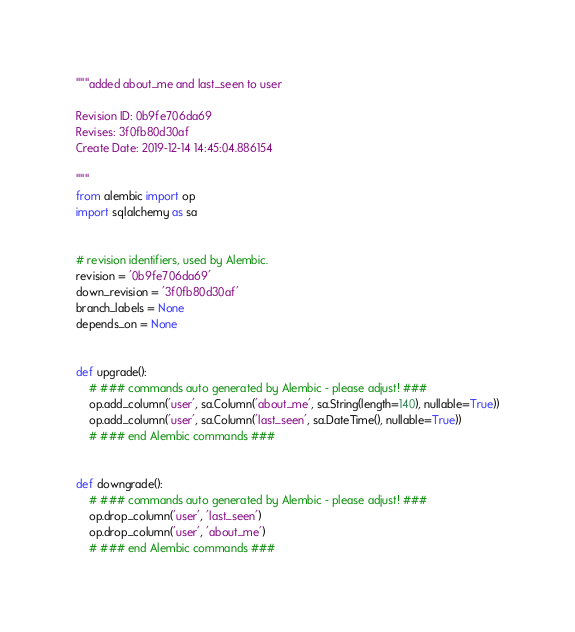Convert code to text. <code><loc_0><loc_0><loc_500><loc_500><_Python_>"""added about_me and last_seen to user

Revision ID: 0b9fe706da69
Revises: 3f0fb80d30af
Create Date: 2019-12-14 14:45:04.886154

"""
from alembic import op
import sqlalchemy as sa


# revision identifiers, used by Alembic.
revision = '0b9fe706da69'
down_revision = '3f0fb80d30af'
branch_labels = None
depends_on = None


def upgrade():
    # ### commands auto generated by Alembic - please adjust! ###
    op.add_column('user', sa.Column('about_me', sa.String(length=140), nullable=True))
    op.add_column('user', sa.Column('last_seen', sa.DateTime(), nullable=True))
    # ### end Alembic commands ###


def downgrade():
    # ### commands auto generated by Alembic - please adjust! ###
    op.drop_column('user', 'last_seen')
    op.drop_column('user', 'about_me')
    # ### end Alembic commands ###
</code> 